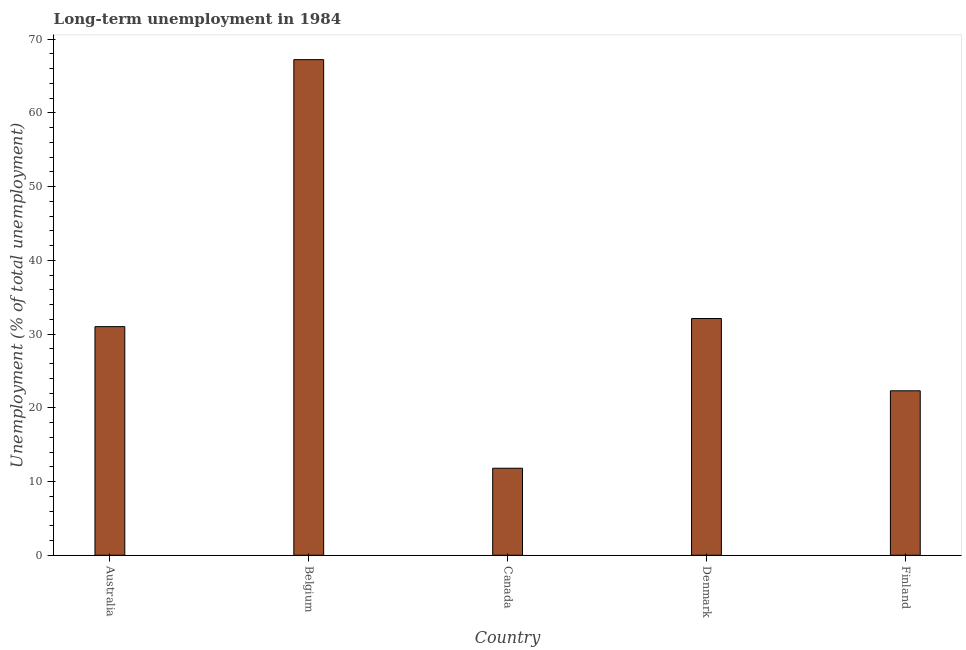What is the title of the graph?
Give a very brief answer. Long-term unemployment in 1984. What is the label or title of the X-axis?
Your response must be concise. Country. What is the label or title of the Y-axis?
Give a very brief answer. Unemployment (% of total unemployment). What is the long-term unemployment in Canada?
Offer a very short reply. 11.8. Across all countries, what is the maximum long-term unemployment?
Give a very brief answer. 67.2. Across all countries, what is the minimum long-term unemployment?
Ensure brevity in your answer.  11.8. In which country was the long-term unemployment maximum?
Provide a succinct answer. Belgium. What is the sum of the long-term unemployment?
Keep it short and to the point. 164.4. What is the difference between the long-term unemployment in Australia and Canada?
Your response must be concise. 19.2. What is the average long-term unemployment per country?
Your answer should be compact. 32.88. What is the median long-term unemployment?
Your answer should be compact. 31. In how many countries, is the long-term unemployment greater than 54 %?
Your answer should be compact. 1. What is the ratio of the long-term unemployment in Belgium to that in Finland?
Offer a very short reply. 3.01. Is the long-term unemployment in Belgium less than that in Denmark?
Provide a short and direct response. No. Is the difference between the long-term unemployment in Belgium and Denmark greater than the difference between any two countries?
Keep it short and to the point. No. What is the difference between the highest and the second highest long-term unemployment?
Provide a succinct answer. 35.1. Is the sum of the long-term unemployment in Canada and Finland greater than the maximum long-term unemployment across all countries?
Offer a terse response. No. What is the difference between the highest and the lowest long-term unemployment?
Keep it short and to the point. 55.4. In how many countries, is the long-term unemployment greater than the average long-term unemployment taken over all countries?
Keep it short and to the point. 1. How many countries are there in the graph?
Your response must be concise. 5. What is the difference between two consecutive major ticks on the Y-axis?
Offer a very short reply. 10. Are the values on the major ticks of Y-axis written in scientific E-notation?
Your answer should be compact. No. What is the Unemployment (% of total unemployment) in Belgium?
Offer a terse response. 67.2. What is the Unemployment (% of total unemployment) in Canada?
Give a very brief answer. 11.8. What is the Unemployment (% of total unemployment) of Denmark?
Offer a very short reply. 32.1. What is the Unemployment (% of total unemployment) of Finland?
Your answer should be very brief. 22.3. What is the difference between the Unemployment (% of total unemployment) in Australia and Belgium?
Your answer should be compact. -36.2. What is the difference between the Unemployment (% of total unemployment) in Australia and Denmark?
Your response must be concise. -1.1. What is the difference between the Unemployment (% of total unemployment) in Belgium and Canada?
Your answer should be very brief. 55.4. What is the difference between the Unemployment (% of total unemployment) in Belgium and Denmark?
Give a very brief answer. 35.1. What is the difference between the Unemployment (% of total unemployment) in Belgium and Finland?
Ensure brevity in your answer.  44.9. What is the difference between the Unemployment (% of total unemployment) in Canada and Denmark?
Your answer should be very brief. -20.3. What is the difference between the Unemployment (% of total unemployment) in Canada and Finland?
Provide a short and direct response. -10.5. What is the difference between the Unemployment (% of total unemployment) in Denmark and Finland?
Your answer should be very brief. 9.8. What is the ratio of the Unemployment (% of total unemployment) in Australia to that in Belgium?
Your response must be concise. 0.46. What is the ratio of the Unemployment (% of total unemployment) in Australia to that in Canada?
Provide a succinct answer. 2.63. What is the ratio of the Unemployment (% of total unemployment) in Australia to that in Denmark?
Ensure brevity in your answer.  0.97. What is the ratio of the Unemployment (% of total unemployment) in Australia to that in Finland?
Offer a very short reply. 1.39. What is the ratio of the Unemployment (% of total unemployment) in Belgium to that in Canada?
Keep it short and to the point. 5.7. What is the ratio of the Unemployment (% of total unemployment) in Belgium to that in Denmark?
Give a very brief answer. 2.09. What is the ratio of the Unemployment (% of total unemployment) in Belgium to that in Finland?
Ensure brevity in your answer.  3.01. What is the ratio of the Unemployment (% of total unemployment) in Canada to that in Denmark?
Offer a terse response. 0.37. What is the ratio of the Unemployment (% of total unemployment) in Canada to that in Finland?
Make the answer very short. 0.53. What is the ratio of the Unemployment (% of total unemployment) in Denmark to that in Finland?
Your response must be concise. 1.44. 